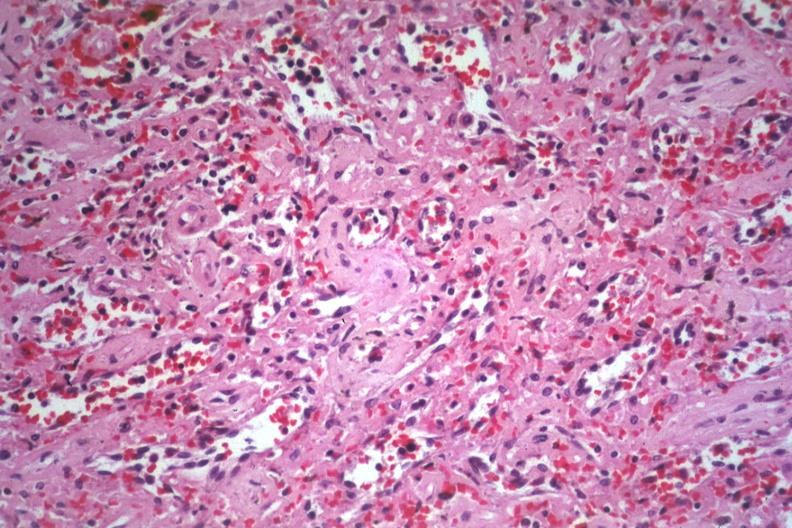s metastatic carcinoma oat cell present?
Answer the question using a single word or phrase. No 